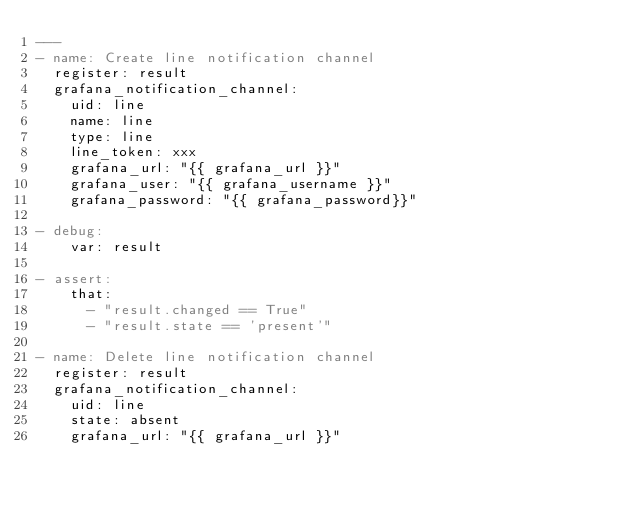Convert code to text. <code><loc_0><loc_0><loc_500><loc_500><_YAML_>---
- name: Create line notification channel
  register: result
  grafana_notification_channel:
    uid: line
    name: line
    type: line
    line_token: xxx
    grafana_url: "{{ grafana_url }}"
    grafana_user: "{{ grafana_username }}"
    grafana_password: "{{ grafana_password}}"

- debug:
    var: result

- assert:
    that:
      - "result.changed == True"
      - "result.state == 'present'"

- name: Delete line notification channel
  register: result
  grafana_notification_channel:
    uid: line
    state: absent
    grafana_url: "{{ grafana_url }}"</code> 